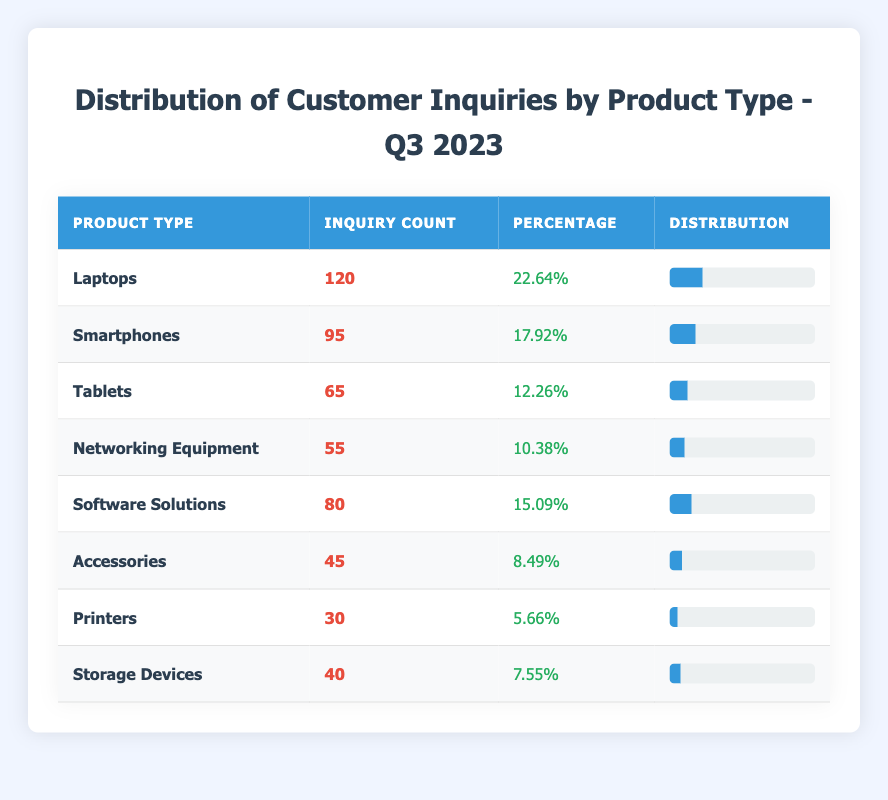What product type received the highest number of customer inquiries? Referring to the table, "Laptops" has the highest inquiry count of 120, which is more than any other product type listed.
Answer: Laptops How many inquiries were received for Tablets? The table shows that "Tablets" had an inquiry count of 65.
Answer: 65 What percentage of inquiries were focused on Accessories? The inquiry count for "Accessories" is 45, and it is stated as 8.49% in the table.
Answer: 8.49% What is the total number of inquiries for all product types? To find this, I need to sum all inquiry counts: 120 (Laptops) + 95 (Smartphones) + 65 (Tablets) + 55 (Networking Equipment) + 80 (Software Solutions) + 45 (Accessories) + 30 (Printers) + 40 (Storage Devices) = 530.
Answer: 530 Is it true that Software Solutions received more inquiries than Networking Equipment? From the table, Software Solutions has 80 inquiries while Networking Equipment has 55 inquiries, which means Software Solutions received more.
Answer: Yes Which product type has the lowest inquiry count, and what is that count? Looking at the table, "Printers" has the lowest inquiry count of 30.
Answer: Printers, 30 If you combine the inquiries for Smartphones and Tablets, how many total inquiries are there? For Smartphones, the inquiry count is 95 and for Tablets, it is 65. Adding these gives 95 + 65 = 160.
Answer: 160 What is the percentage of inquiries for Storage Devices relative to the total inquiries? The inquiry count for Storage Devices is 40. To find the percentage, I divide 40 by the total inquiries (530) and multiply by 100: (40 / 530) * 100 = 7.55%.
Answer: 7.55% Is there a product type with exactly 50 inquiries? The table shows no product type with exactly 50 inquiries; the closest counts are 55 (Networking Equipment) and 45 (Accessories).
Answer: No 